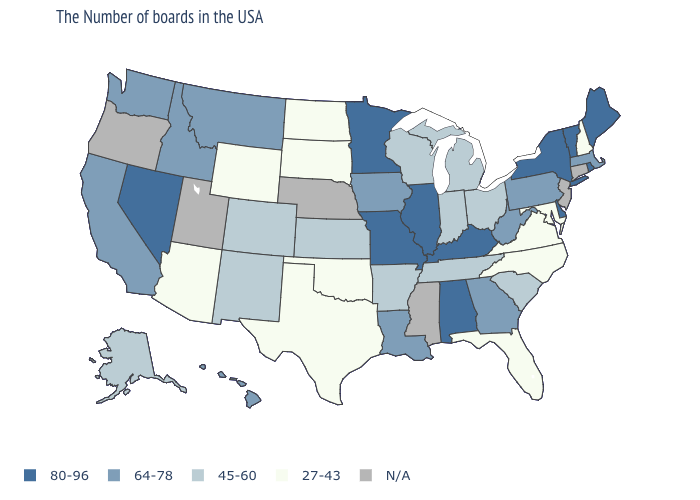What is the value of California?
Give a very brief answer. 64-78. What is the value of Oregon?
Short answer required. N/A. How many symbols are there in the legend?
Give a very brief answer. 5. Does the map have missing data?
Give a very brief answer. Yes. Name the states that have a value in the range N/A?
Answer briefly. Connecticut, New Jersey, Mississippi, Nebraska, Utah, Oregon. Does Minnesota have the highest value in the USA?
Keep it brief. Yes. How many symbols are there in the legend?
Write a very short answer. 5. Among the states that border Virginia , does Tennessee have the highest value?
Keep it brief. No. Name the states that have a value in the range 27-43?
Concise answer only. New Hampshire, Maryland, Virginia, North Carolina, Florida, Oklahoma, Texas, South Dakota, North Dakota, Wyoming, Arizona. What is the highest value in states that border Virginia?
Write a very short answer. 80-96. Among the states that border Wisconsin , which have the lowest value?
Concise answer only. Michigan. What is the highest value in the MidWest ?
Give a very brief answer. 80-96. 